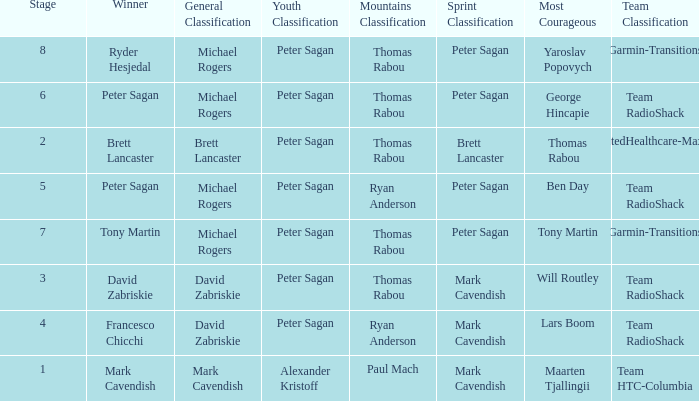When Brett Lancaster won the general classification, who won the team calssification? UnitedHealthcare-Maxxis. 